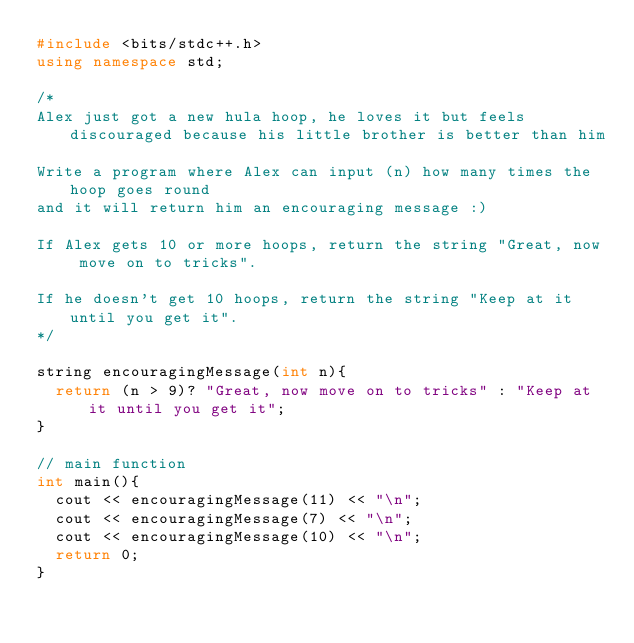Convert code to text. <code><loc_0><loc_0><loc_500><loc_500><_C++_>#include <bits/stdc++.h>
using namespace std;

/*
Alex just got a new hula hoop, he loves it but feels discouraged because his little brother is better than him

Write a program where Alex can input (n) how many times the hoop goes round
and it will return him an encouraging message :)

If Alex gets 10 or more hoops, return the string "Great, now move on to tricks".

If he doesn't get 10 hoops, return the string "Keep at it until you get it".
*/

string encouragingMessage(int n){
	return (n > 9)? "Great, now move on to tricks" : "Keep at it until you get it";
}

// main function
int main(){
	cout << encouragingMessage(11) << "\n";
	cout << encouragingMessage(7) << "\n";
	cout << encouragingMessage(10) << "\n";
	return 0;
}</code> 